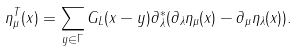<formula> <loc_0><loc_0><loc_500><loc_500>\eta ^ { T } _ { \mu } ( x ) = \sum _ { y \in \Gamma } G _ { L } ( x - y ) \partial _ { \lambda } ^ { \ast } ( \partial _ { \lambda } \eta _ { \mu } ( x ) - \partial _ { \mu } \eta _ { \lambda } ( x ) ) .</formula> 